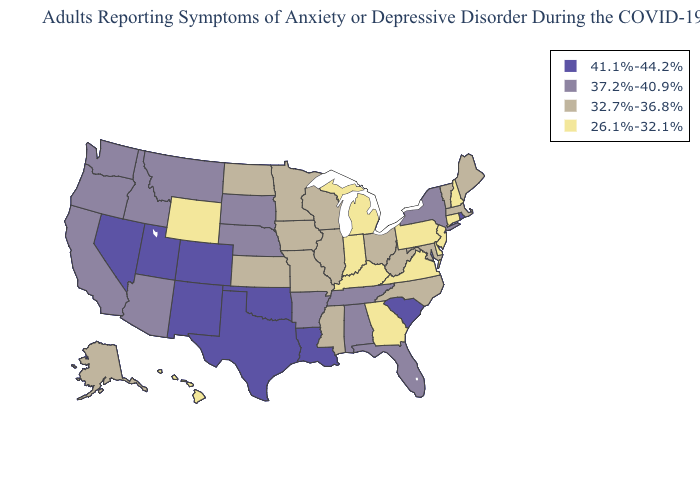What is the value of Arizona?
Write a very short answer. 37.2%-40.9%. Does Wyoming have the highest value in the West?
Write a very short answer. No. Among the states that border Maryland , does Delaware have the highest value?
Give a very brief answer. No. Does Kansas have the same value as Colorado?
Keep it brief. No. Name the states that have a value in the range 37.2%-40.9%?
Keep it brief. Alabama, Arizona, Arkansas, California, Florida, Idaho, Montana, Nebraska, New York, Oregon, South Dakota, Tennessee, Washington. What is the lowest value in the South?
Write a very short answer. 26.1%-32.1%. Name the states that have a value in the range 26.1%-32.1%?
Answer briefly. Connecticut, Delaware, Georgia, Hawaii, Indiana, Kentucky, Michigan, New Hampshire, New Jersey, Pennsylvania, Virginia, Wyoming. What is the lowest value in the West?
Write a very short answer. 26.1%-32.1%. Which states hav the highest value in the West?
Quick response, please. Colorado, Nevada, New Mexico, Utah. What is the value of Texas?
Concise answer only. 41.1%-44.2%. Name the states that have a value in the range 26.1%-32.1%?
Be succinct. Connecticut, Delaware, Georgia, Hawaii, Indiana, Kentucky, Michigan, New Hampshire, New Jersey, Pennsylvania, Virginia, Wyoming. What is the value of Tennessee?
Write a very short answer. 37.2%-40.9%. Name the states that have a value in the range 26.1%-32.1%?
Write a very short answer. Connecticut, Delaware, Georgia, Hawaii, Indiana, Kentucky, Michigan, New Hampshire, New Jersey, Pennsylvania, Virginia, Wyoming. Does Illinois have a higher value than Oklahoma?
Answer briefly. No. Does the first symbol in the legend represent the smallest category?
Short answer required. No. 